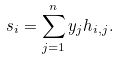<formula> <loc_0><loc_0><loc_500><loc_500>s _ { i } = \sum _ { j = 1 } ^ { n } y _ { j } h _ { i , j } .</formula> 